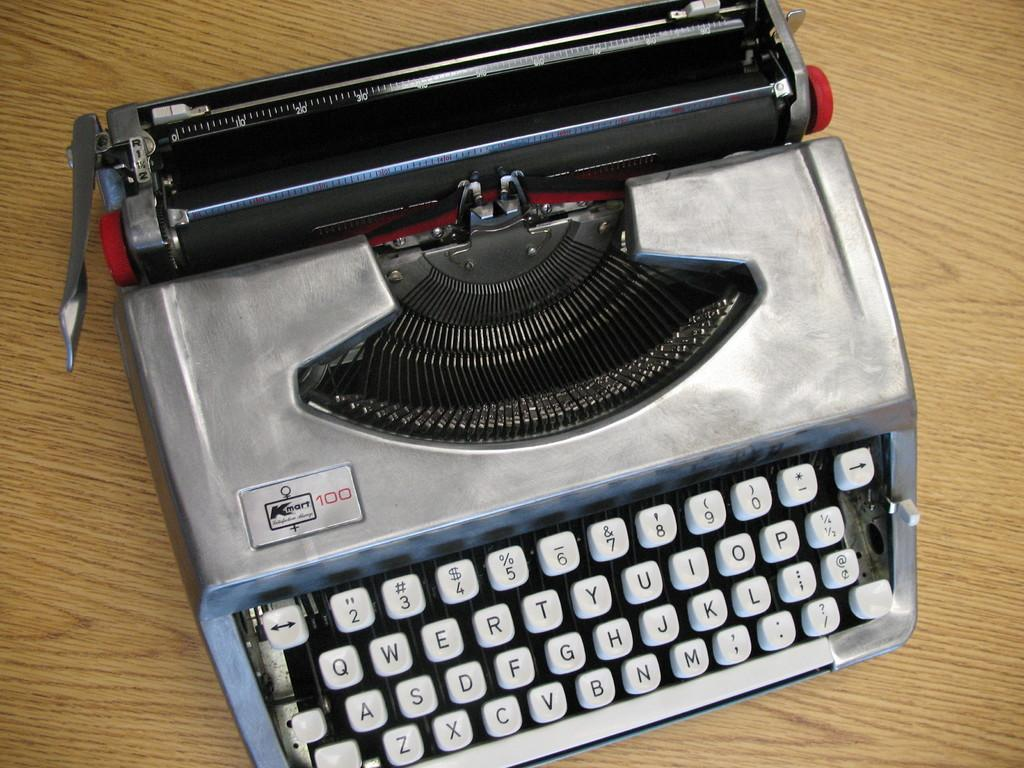<image>
Describe the image concisely. the letter T is on the typewriter that is gray 